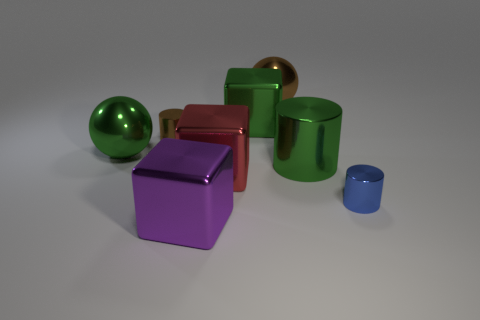Subtract all gray cylinders. Subtract all gray blocks. How many cylinders are left? 3 Add 1 blue cylinders. How many objects exist? 9 Subtract all cubes. How many objects are left? 5 Add 7 red cubes. How many red cubes exist? 8 Subtract 0 gray balls. How many objects are left? 8 Subtract all large purple rubber balls. Subtract all green shiny balls. How many objects are left? 7 Add 6 tiny metallic cylinders. How many tiny metallic cylinders are left? 8 